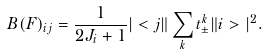<formula> <loc_0><loc_0><loc_500><loc_500>B ( F ) _ { i j } = \frac { 1 } { 2 J _ { i } + 1 } | < j \| \sum _ { k } t _ { \pm } ^ { k } \| i > | ^ { 2 } .</formula> 